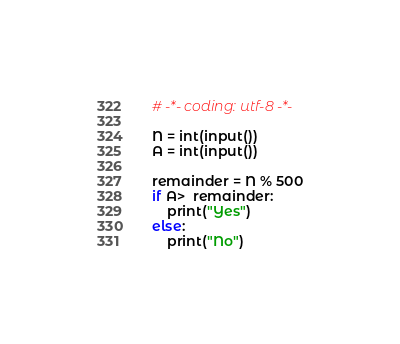<code> <loc_0><loc_0><loc_500><loc_500><_Python_># -*- coding: utf-8 -*-

N = int(input())
A = int(input())

remainder = N % 500
if A>  remainder:
    print("Yes")
else:
    print("No")</code> 